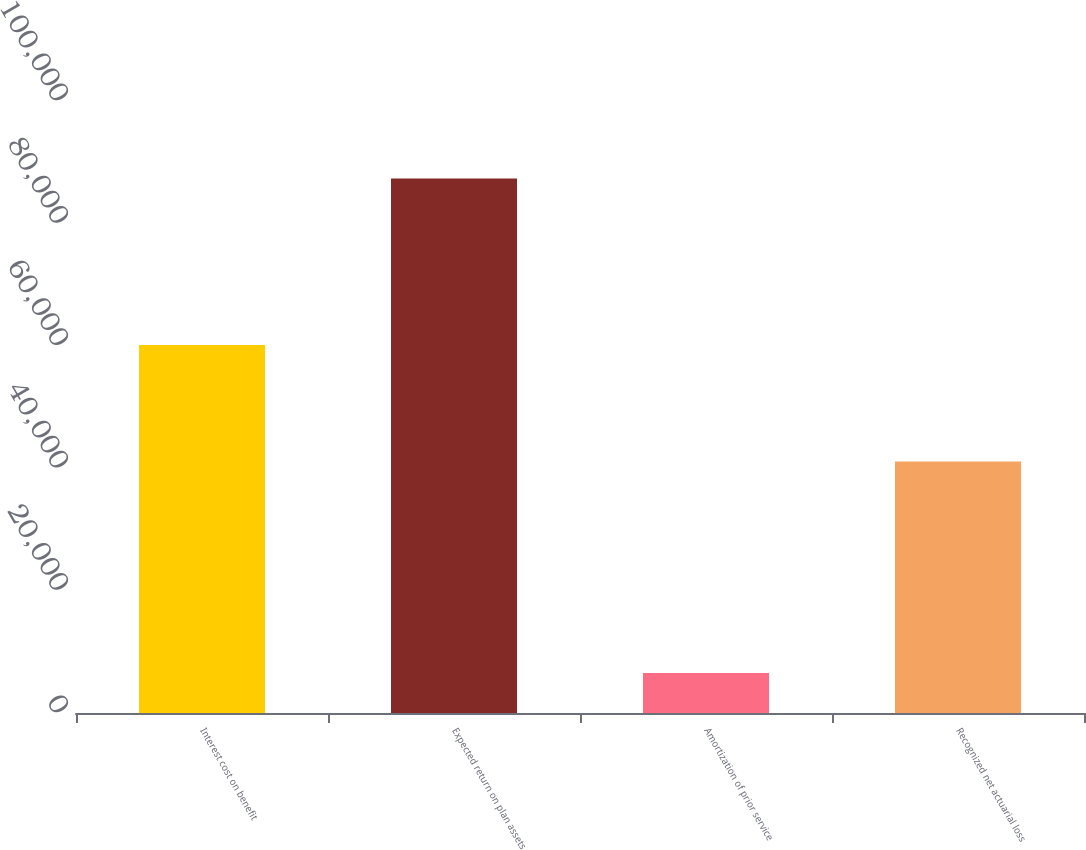<chart> <loc_0><loc_0><loc_500><loc_500><bar_chart><fcel>Interest cost on benefit<fcel>Expected return on plan assets<fcel>Amortization of prior service<fcel>Recognized net actuarial loss<nl><fcel>60130<fcel>87353<fcel>6556<fcel>41076<nl></chart> 